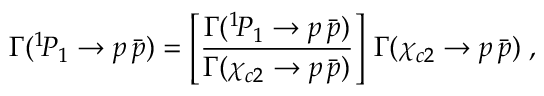Convert formula to latex. <formula><loc_0><loc_0><loc_500><loc_500>\Gamma ( ^ { 1 } \, P _ { 1 } \to p \, \bar { p } ) = \left [ \frac { \Gamma ( ^ { 1 } \, P _ { 1 } \to p \, \bar { p } ) } { \Gamma ( \chi _ { c 2 } \to p \, \bar { p } ) } \right ] \, \Gamma ( \chi _ { c 2 } \to p \, \bar { p } ) \, ,</formula> 